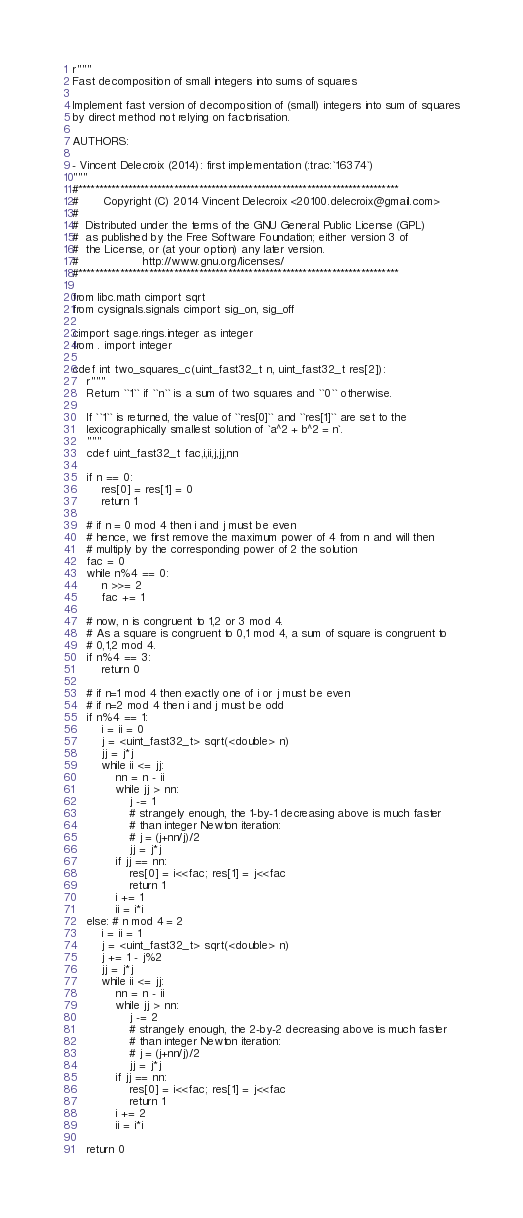Convert code to text. <code><loc_0><loc_0><loc_500><loc_500><_Cython_>r"""
Fast decomposition of small integers into sums of squares

Implement fast version of decomposition of (small) integers into sum of squares
by direct method not relying on factorisation.

AUTHORS:

- Vincent Delecroix (2014): first implementation (:trac:`16374`)
"""
#*****************************************************************************
#       Copyright (C) 2014 Vincent Delecroix <20100.delecroix@gmail.com>
#
#  Distributed under the terms of the GNU General Public License (GPL)
#  as published by the Free Software Foundation; either version 3 of
#  the License, or (at your option) any later version.
#                  http://www.gnu.org/licenses/
#*****************************************************************************

from libc.math cimport sqrt
from cysignals.signals cimport sig_on, sig_off

cimport sage.rings.integer as integer
from . import integer

cdef int two_squares_c(uint_fast32_t n, uint_fast32_t res[2]):
    r"""
    Return ``1`` if ``n`` is a sum of two squares and ``0`` otherwise.

    If ``1`` is returned, the value of ``res[0]`` and ``res[1]`` are set to the
    lexicographically smallest solution of `a^2 + b^2 = n`.
    """
    cdef uint_fast32_t fac,i,ii,j,jj,nn

    if n == 0:
        res[0] = res[1] = 0
        return 1

    # if n = 0 mod 4 then i and j must be even
    # hence, we first remove the maximum power of 4 from n and will then
    # multiply by the corresponding power of 2 the solution
    fac = 0
    while n%4 == 0:
        n >>= 2
        fac += 1

    # now, n is congruent to 1,2 or 3 mod 4.
    # As a square is congruent to 0,1 mod 4, a sum of square is congruent to
    # 0,1,2 mod 4.
    if n%4 == 3:
        return 0

    # if n=1 mod 4 then exactly one of i or j must be even
    # if n=2 mod 4 then i and j must be odd
    if n%4 == 1:
        i = ii = 0
        j = <uint_fast32_t> sqrt(<double> n)
        jj = j*j
        while ii <= jj:
            nn = n - ii
            while jj > nn:
                j -= 1
                # strangely enough, the 1-by-1 decreasing above is much faster
                # than integer Newton iteration:
                # j = (j+nn/j)/2
                jj = j*j
            if jj == nn:
                res[0] = i<<fac; res[1] = j<<fac
                return 1
            i += 1
            ii = i*i
    else: # n mod 4 = 2
        i = ii = 1
        j = <uint_fast32_t> sqrt(<double> n)
        j += 1 - j%2
        jj = j*j
        while ii <= jj:
            nn = n - ii
            while jj > nn:
                j -= 2
                # strangely enough, the 2-by-2 decreasing above is much faster
                # than integer Newton iteration:
                # j = (j+nn/j)/2
                jj = j*j
            if jj == nn:
                res[0] = i<<fac; res[1] = j<<fac
                return 1
            i += 2
            ii = i*i

    return 0

</code> 